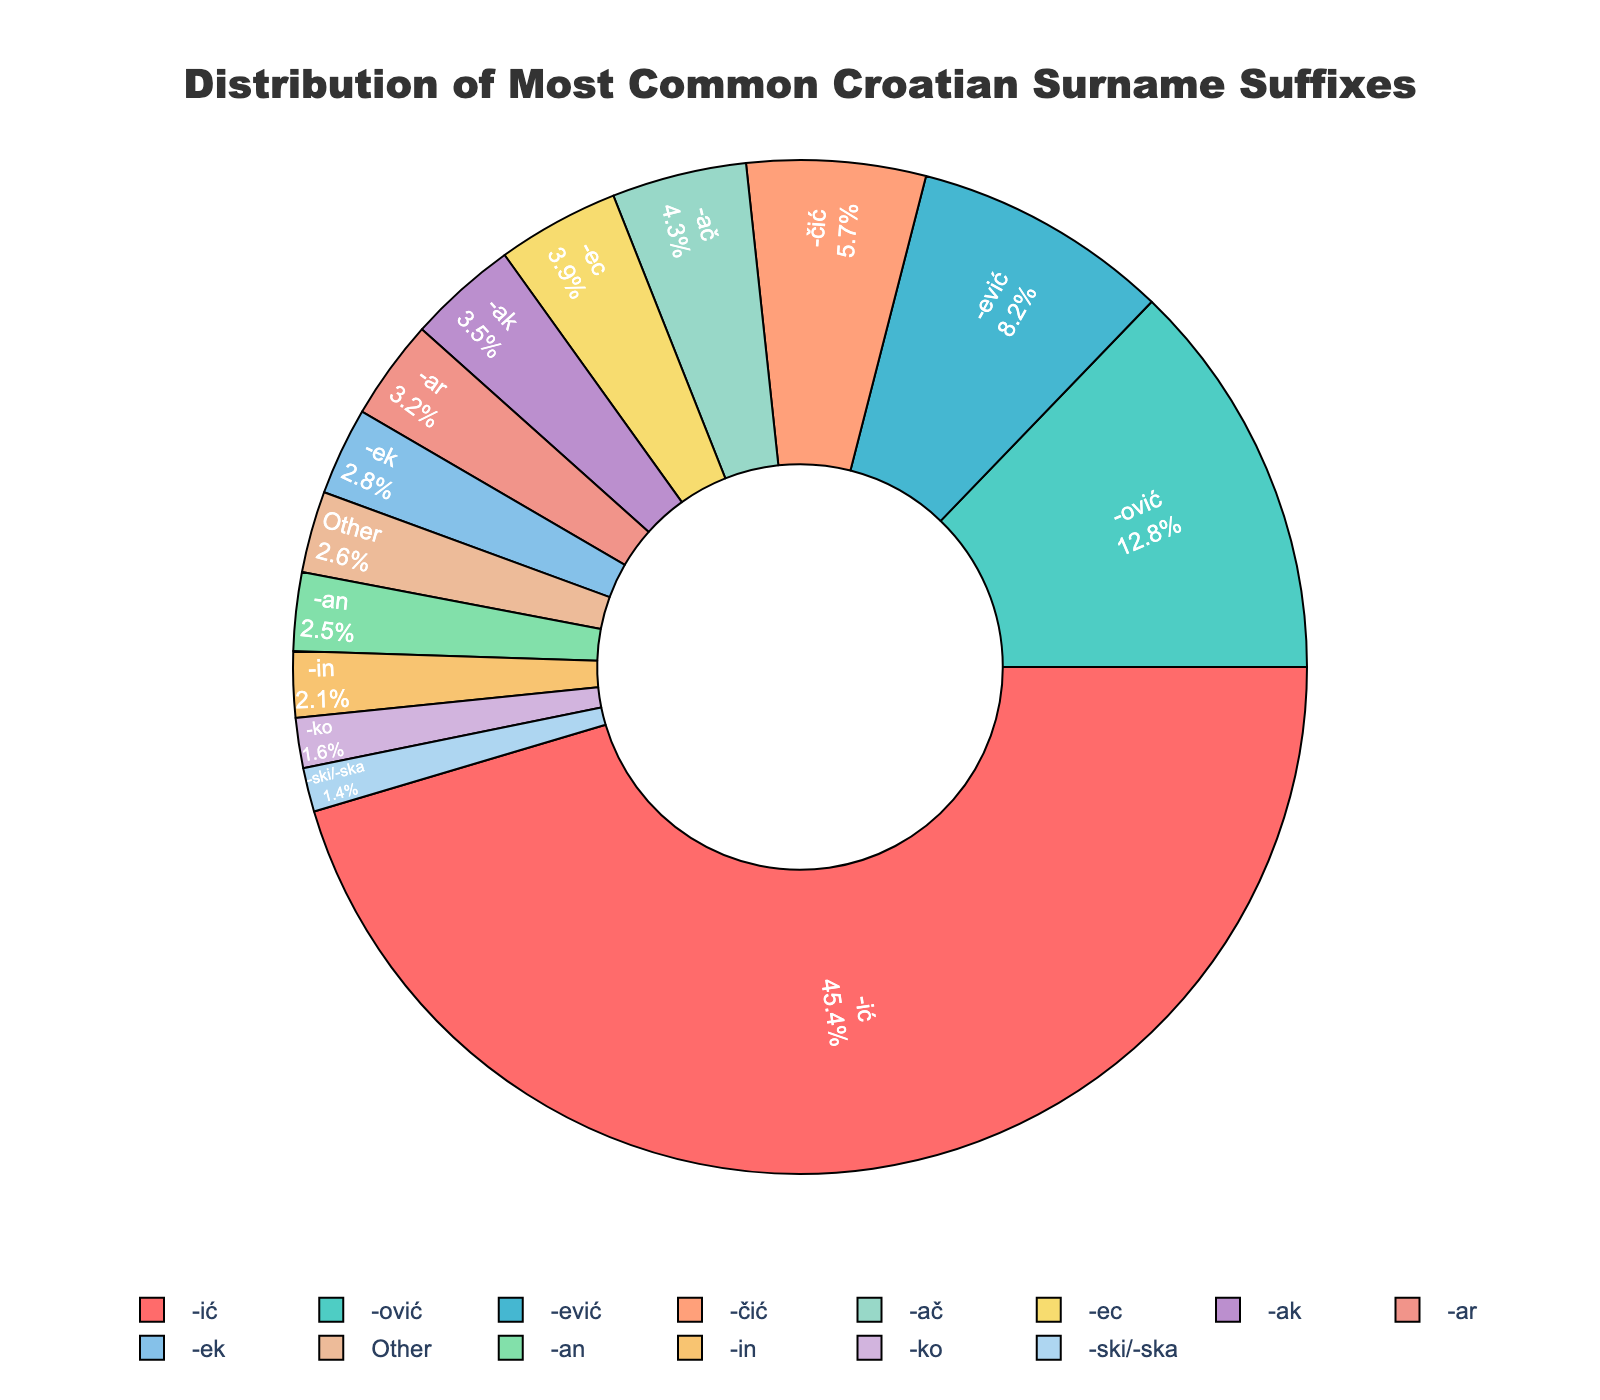Which suffix has the highest percentage? The suffix with the highest percentage occupies the largest portion of the pie chart. The -ić suffix dominates the chart.
Answer: -ić What is the combined percentage of suffixes that end in -ić, -ović, and -ević? Add the percentages of suffixes -ić (43.5%), -ović (12.8%), and -ević (8.2%) together: 43.5 + 12.8 + 8.2 = 64.5%.
Answer: 64.5% How much larger is the percentage of -ić compared to -ović? Subtract the percentage of -ović (12.8%) from -ić (43.5%): 43.5 - 12.8 = 30.7%.
Answer: 30.7% Among the given suffixes, which has the smallest percentage, and what is its value? The smallest segment in the pie chart corresponds to the suffix with the lowest percentage. The suffix -ski/-ska has the smallest percentage.
Answer: -ski/-ska, 1.4% How do the combined percentages of suffixes ending in -čić, -ač, and -ec compare to the percentage of -ović? Add the percentages of -čić (5.7%), -ač (4.3%), and -ec (3.9%) together: 5.7 + 4.3 + 3.9 = 13.9%. Then compare this combined value to the percentage of -ović (12.8%): 13.9% is slightly higher than 12.8%.
Answer: Combined 13.9% is higher than 12.8% What is the relative difference between the suffixes -ak and -an? Subtract the percentage of -an (2.5%) from -ak (3.5%): 3.5 - 2.5 = 1%.
Answer: 1% Are there any suffixes that have the same percentage, and if so, which ones? Examine the pie chart to see if any slices have the same value. The suffixes -ek and -in both have percentages of 2.1%.
Answer: -ek and -in, 2.1% What percentage of the suffixes combined fall under "Other"? The "Other" category has a given percentage directly in the pie chart.
Answer: 2.6% Which suffix category is represented by the light blue color in the chart? Identify the light blue segment in the pie chart for its corresponding suffix. In this case, -ec is associated with the light blue color.
Answer: -ec 